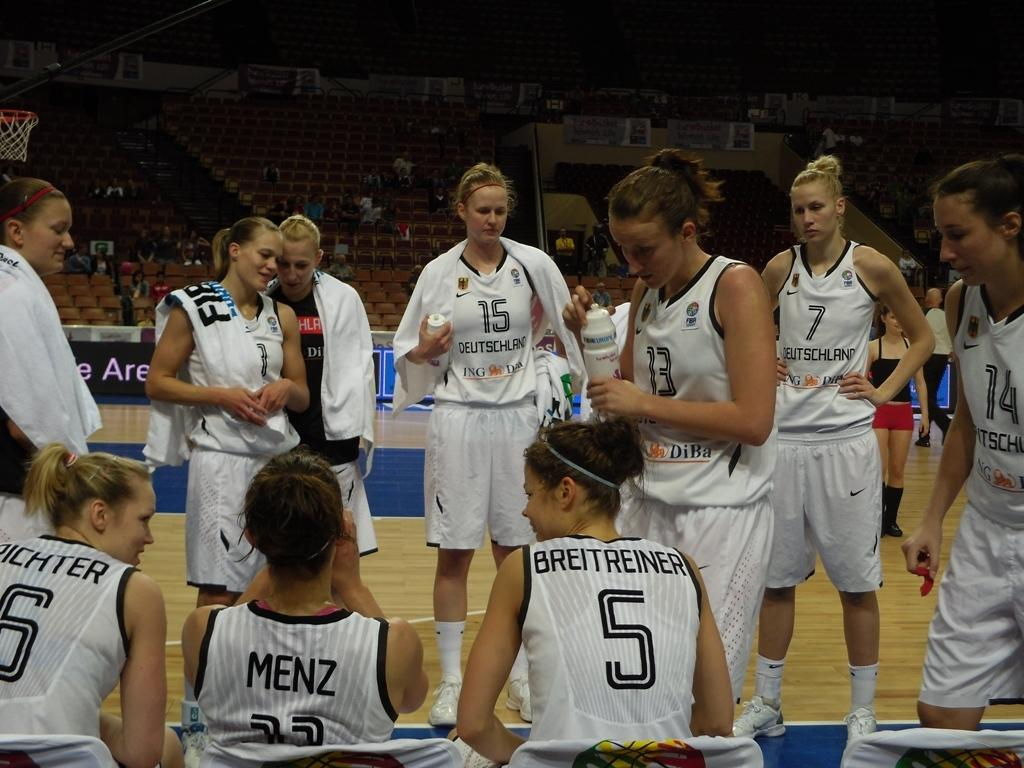<image>
Describe the image concisely. a few players including one with the number 5 on their back 